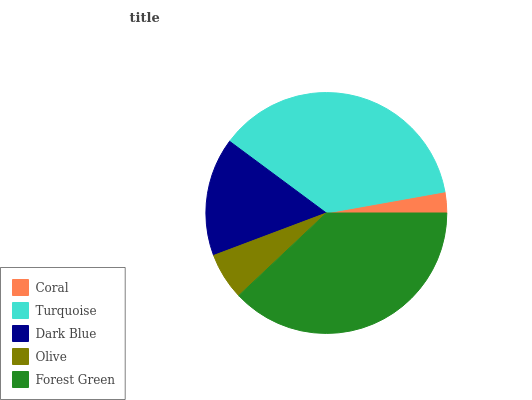Is Coral the minimum?
Answer yes or no. Yes. Is Forest Green the maximum?
Answer yes or no. Yes. Is Turquoise the minimum?
Answer yes or no. No. Is Turquoise the maximum?
Answer yes or no. No. Is Turquoise greater than Coral?
Answer yes or no. Yes. Is Coral less than Turquoise?
Answer yes or no. Yes. Is Coral greater than Turquoise?
Answer yes or no. No. Is Turquoise less than Coral?
Answer yes or no. No. Is Dark Blue the high median?
Answer yes or no. Yes. Is Dark Blue the low median?
Answer yes or no. Yes. Is Coral the high median?
Answer yes or no. No. Is Forest Green the low median?
Answer yes or no. No. 